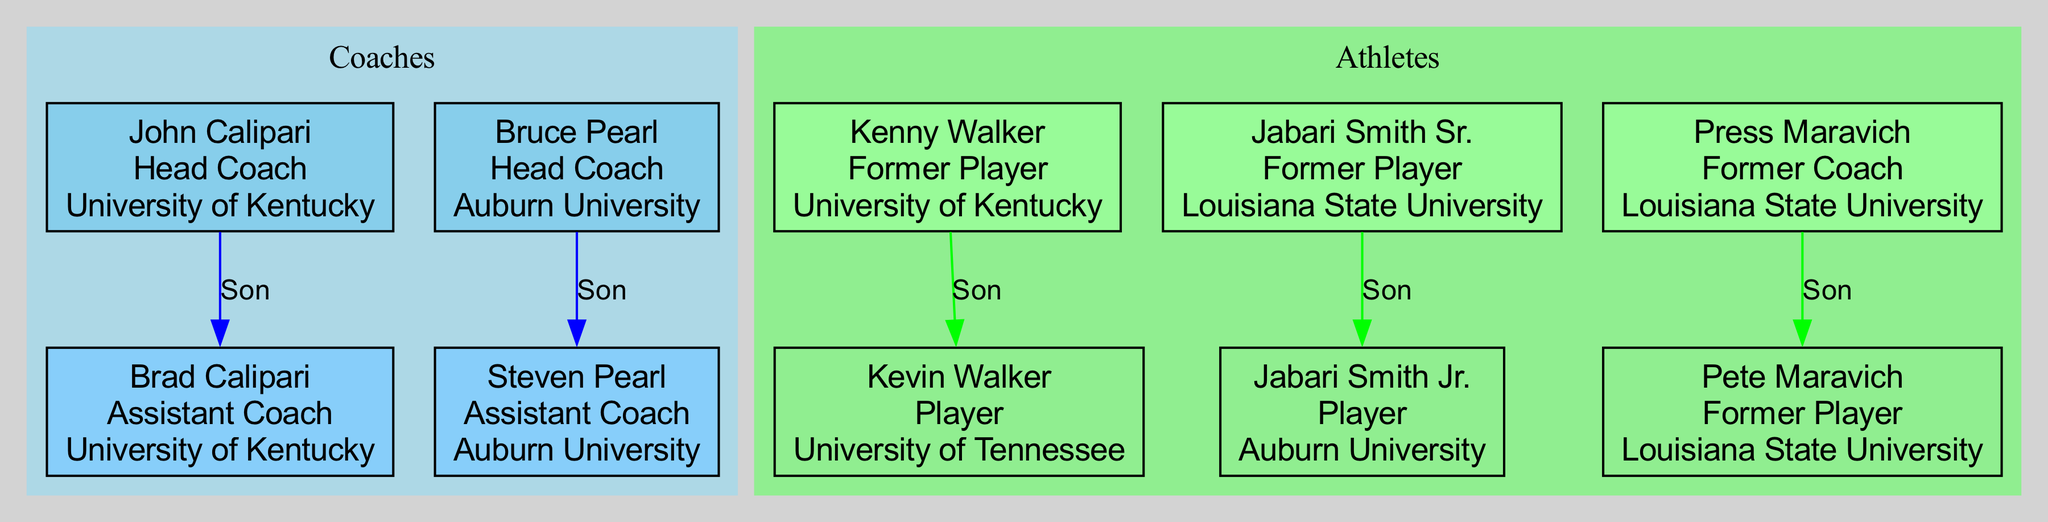What is the team of John Calipari? The diagram shows that John Calipari is the Head Coach at the University of Kentucky, which is indicated right next to his name.
Answer: University of Kentucky How many children does Bruce Pearl have? By examining Bruce Pearl's section in the diagram, it is clear that he has one child, Steven Pearl, listed under him.
Answer: 1 Who is the son of Kenny Walker? The diagram specifically displays that Kevin Walker is the son of Kenny Walker, with a direct connection drawn from Kenny to Kevin.
Answer: Kevin Walker What relationship does Brad Calipari have with John Calipari? The diagram clearly displays an edge from John Calipari to Brad Calipari, labeled "Son," indicating the parent-child relationship.
Answer: Son Which teams are represented by the children of the coaches? The children of the coaches are associated with specific teams, as seen in the diagram: Brad Calipari is with the University of Kentucky and Steven Pearl is with Auburn University. This provides two distinct team affiliations.
Answer: University of Kentucky, Auburn University How many former players have children listed in the diagram? Upon reviewing the diagram, it shows three former players: Kenny Walker, Jabari Smith Sr., and Press Maravich. Each of them has a child listed, confirming that all have children shown in the family tree.
Answer: 3 What is the position of Jabari Smith Jr.? According to the diagram, Jabari Smith Jr. is listed as a Player under the team Auburn University, indicating his current role in basketball.
Answer: Player Which coach and athlete share the same team? The diagram indicates that both Bruce Pearl and his son Steven Pearl are associated with Auburn University, highlighting the shared connection to the same team.
Answer: Auburn University How many edges are connected to Press Maravich? In the diagram, there is one direct connection visible from Press Maravich to his son, Pete Maravich, indicating that there is one edge present.
Answer: 1 